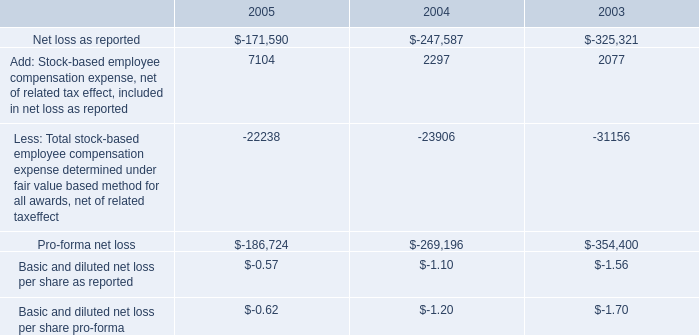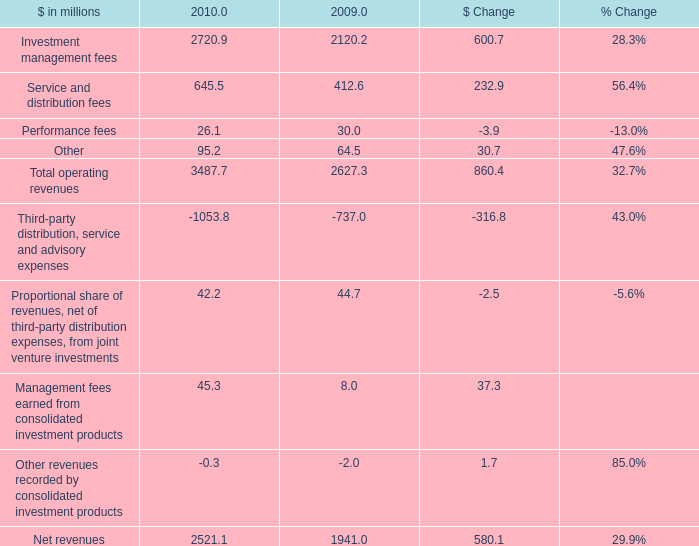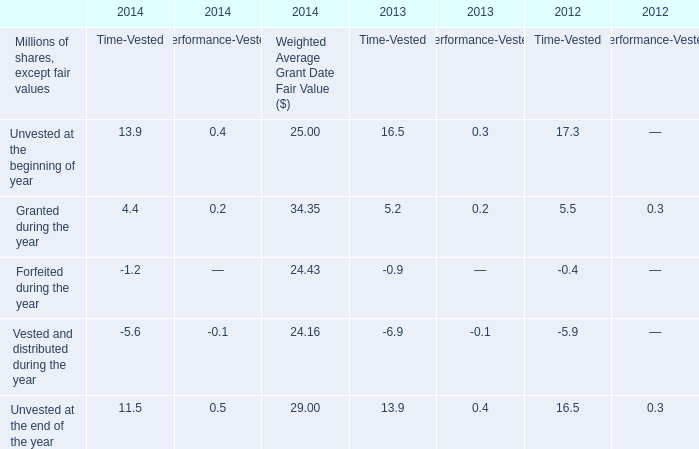what was the percentage decrease in the pro-forma net loss 
Computations: ((-186724 - -269196) / -269196)
Answer: -0.30636. 